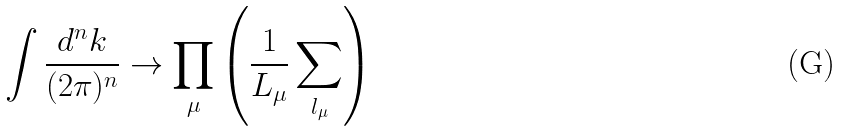Convert formula to latex. <formula><loc_0><loc_0><loc_500><loc_500>\int \frac { d ^ { n } k } { ( 2 \pi ) ^ { n } } \rightarrow \prod _ { \mu } \left ( \frac { 1 } { L _ { \mu } } \sum _ { l _ { \mu } } \right )</formula> 